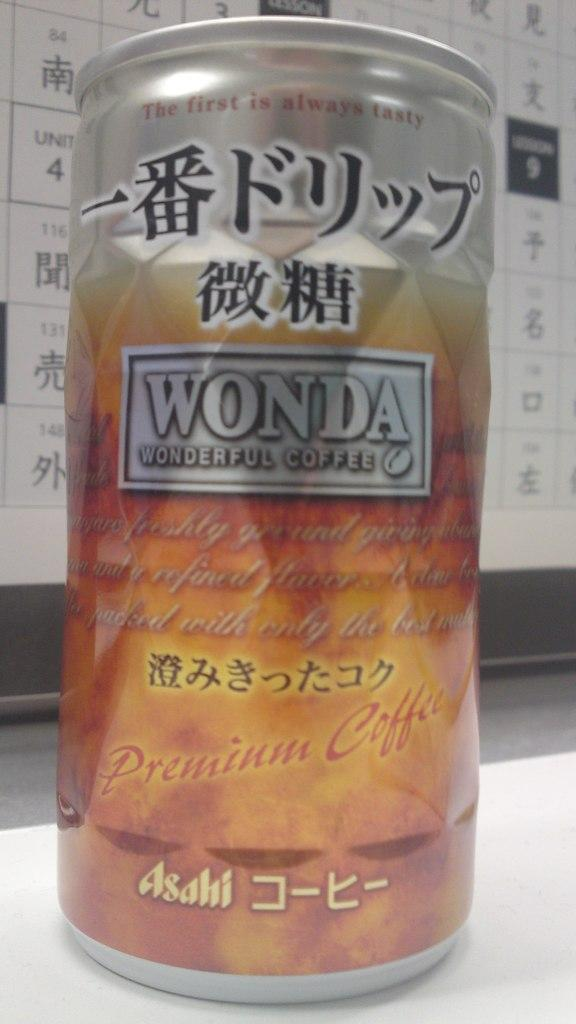<image>
Create a compact narrative representing the image presented. Wonda wonderful coffee sits on a table with a chart of Chinese letters behind it. 